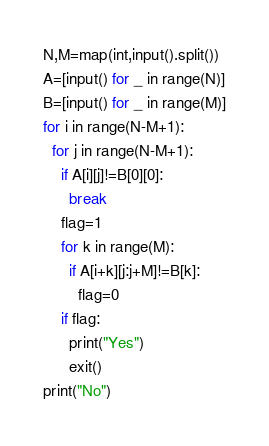Convert code to text. <code><loc_0><loc_0><loc_500><loc_500><_Python_>N,M=map(int,input().split())
A=[input() for _ in range(N)]
B=[input() for _ in range(M)]
for i in range(N-M+1):
  for j in range(N-M+1):
    if A[i][j]!=B[0][0]:
      break
    flag=1
    for k in range(M):
      if A[i+k][j:j+M]!=B[k]:
        flag=0
    if flag:
      print("Yes")
      exit()
print("No")</code> 